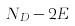<formula> <loc_0><loc_0><loc_500><loc_500>N _ { D } - 2 E</formula> 